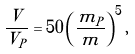Convert formula to latex. <formula><loc_0><loc_0><loc_500><loc_500>\frac { V } { V _ { P } } = 5 0 \left ( \frac { m _ { P } } { m } \right ) ^ { 5 } ,</formula> 